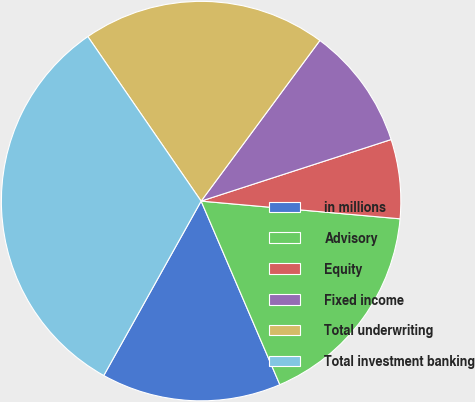Convert chart. <chart><loc_0><loc_0><loc_500><loc_500><pie_chart><fcel>in millions<fcel>Advisory<fcel>Equity<fcel>Fixed income<fcel>Total underwriting<fcel>Total investment banking<nl><fcel>14.55%<fcel>17.14%<fcel>6.4%<fcel>9.88%<fcel>19.73%<fcel>32.3%<nl></chart> 